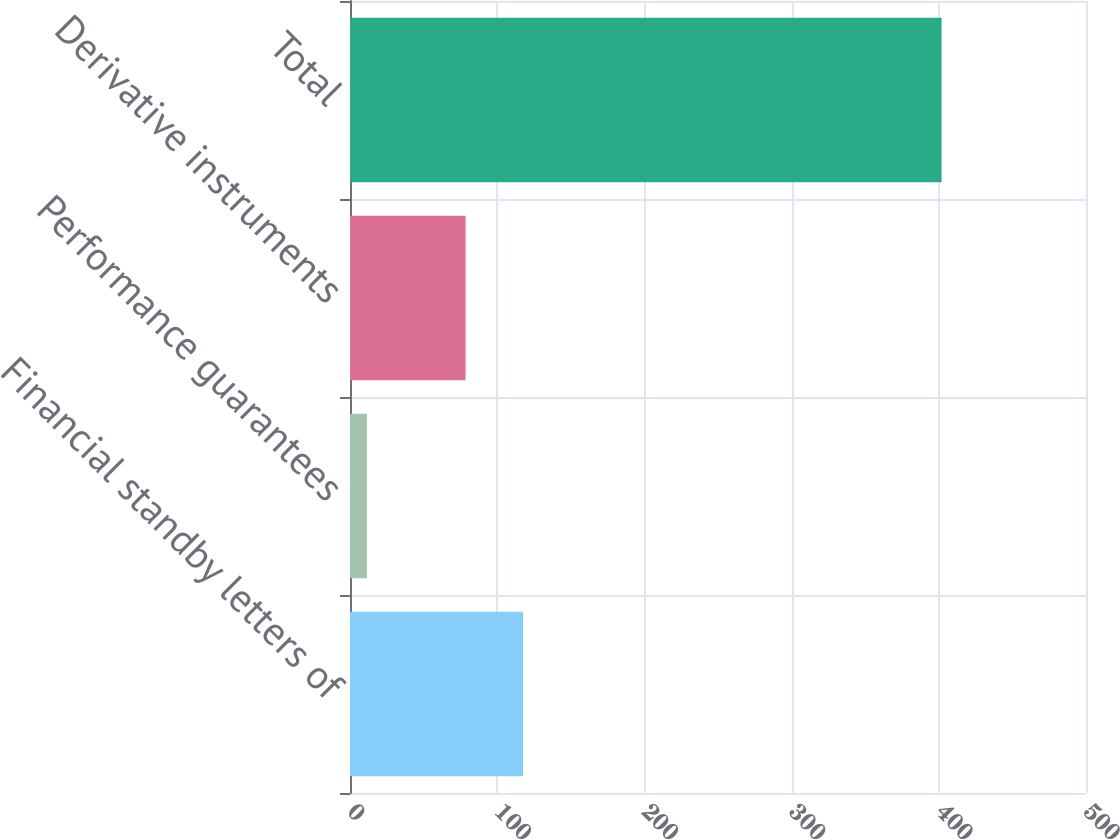Convert chart to OTSL. <chart><loc_0><loc_0><loc_500><loc_500><bar_chart><fcel>Financial standby letters of<fcel>Performance guarantees<fcel>Derivative instruments<fcel>Total<nl><fcel>117.54<fcel>11.5<fcel>78.5<fcel>401.9<nl></chart> 